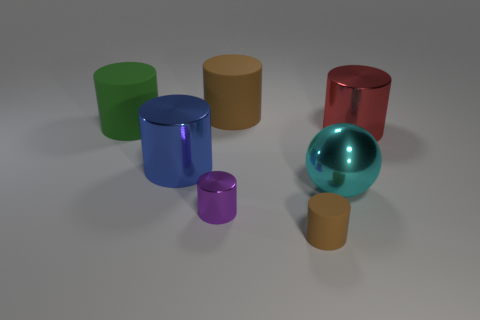What size is the rubber cylinder that is in front of the metallic sphere?
Give a very brief answer. Small. There is a cylinder right of the brown rubber cylinder right of the big rubber cylinder that is behind the large green cylinder; what is its color?
Your answer should be compact. Red. What is the color of the rubber cylinder that is in front of the large metal cylinder that is right of the small purple thing?
Your response must be concise. Brown. Is the number of big objects that are to the right of the large green object greater than the number of big balls behind the red object?
Provide a succinct answer. Yes. Is the brown thing that is in front of the large cyan shiny thing made of the same material as the red object that is in front of the large brown rubber thing?
Offer a terse response. No. Are there any large metal cylinders behind the big blue thing?
Ensure brevity in your answer.  Yes. What number of yellow things are either spheres or big shiny cylinders?
Provide a succinct answer. 0. Are the tiny brown cylinder and the brown thing behind the ball made of the same material?
Ensure brevity in your answer.  Yes. There is a green object that is the same shape as the blue metallic thing; what is its size?
Give a very brief answer. Large. What is the material of the large green object?
Your answer should be very brief. Rubber. 